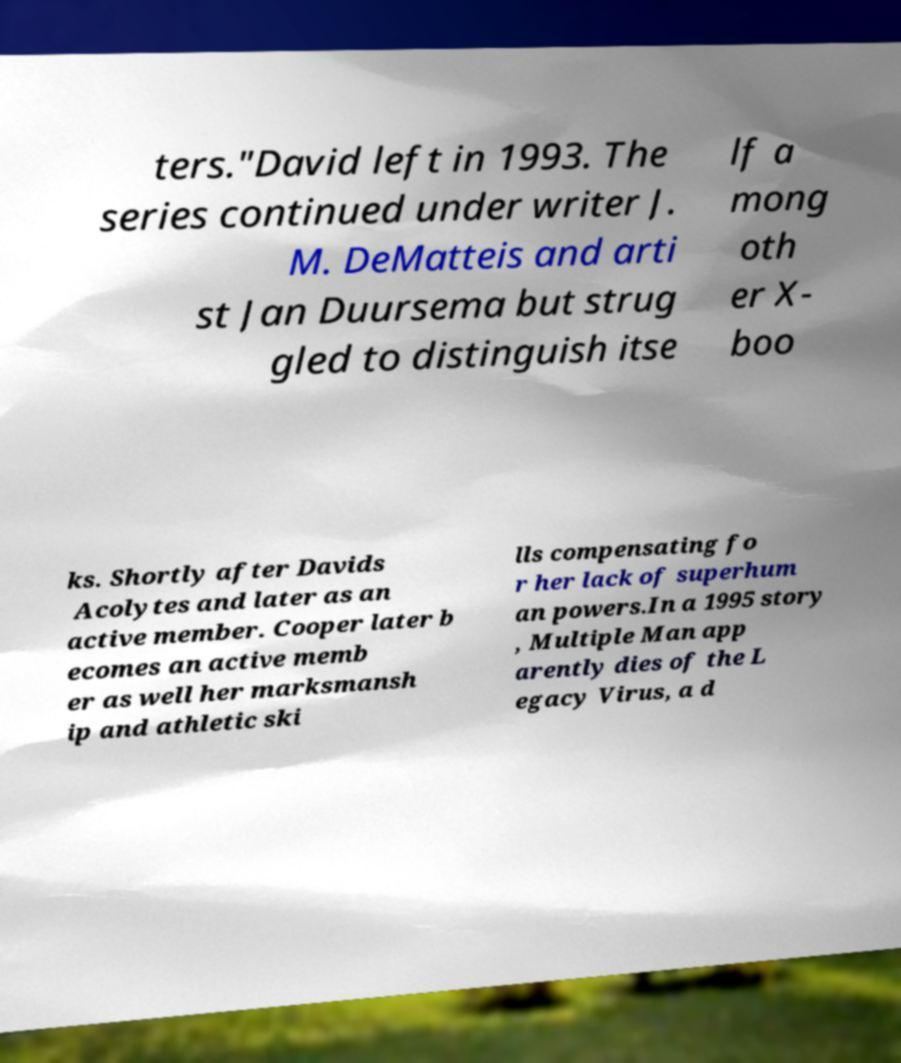Please identify and transcribe the text found in this image. ters."David left in 1993. The series continued under writer J. M. DeMatteis and arti st Jan Duursema but strug gled to distinguish itse lf a mong oth er X- boo ks. Shortly after Davids Acolytes and later as an active member. Cooper later b ecomes an active memb er as well her marksmansh ip and athletic ski lls compensating fo r her lack of superhum an powers.In a 1995 story , Multiple Man app arently dies of the L egacy Virus, a d 